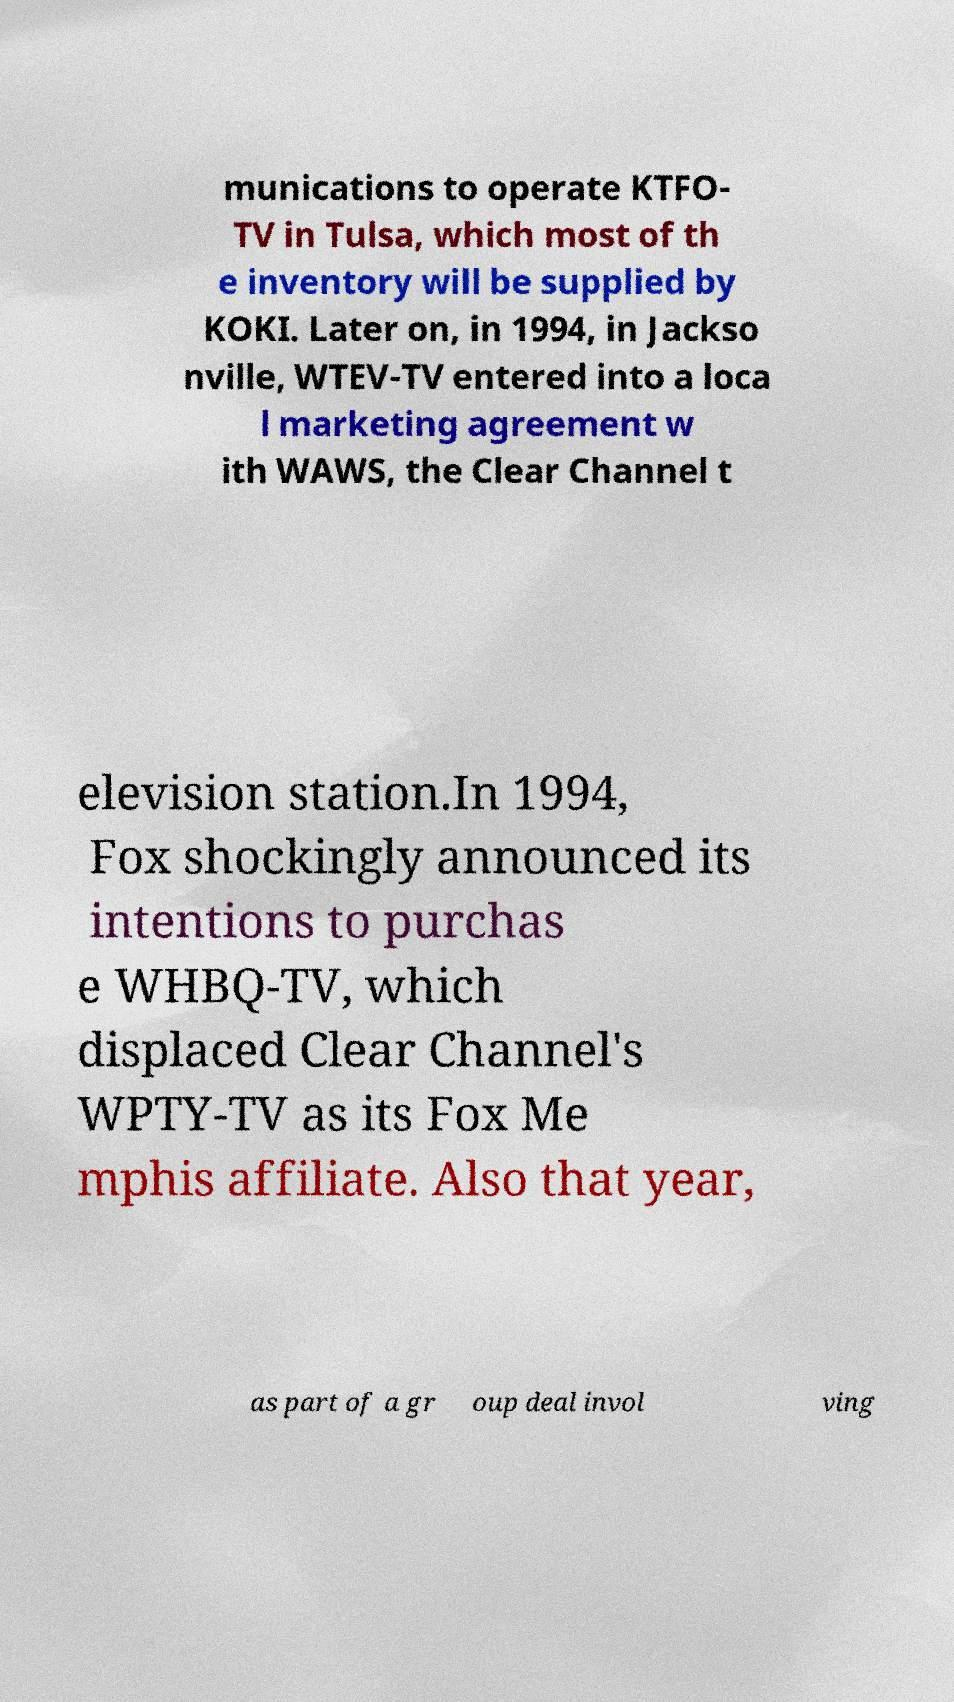Could you extract and type out the text from this image? munications to operate KTFO- TV in Tulsa, which most of th e inventory will be supplied by KOKI. Later on, in 1994, in Jackso nville, WTEV-TV entered into a loca l marketing agreement w ith WAWS, the Clear Channel t elevision station.In 1994, Fox shockingly announced its intentions to purchas e WHBQ-TV, which displaced Clear Channel's WPTY-TV as its Fox Me mphis affiliate. Also that year, as part of a gr oup deal invol ving 